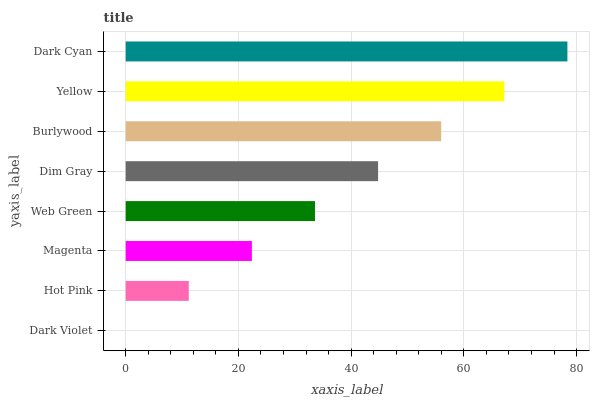Is Dark Violet the minimum?
Answer yes or no. Yes. Is Dark Cyan the maximum?
Answer yes or no. Yes. Is Hot Pink the minimum?
Answer yes or no. No. Is Hot Pink the maximum?
Answer yes or no. No. Is Hot Pink greater than Dark Violet?
Answer yes or no. Yes. Is Dark Violet less than Hot Pink?
Answer yes or no. Yes. Is Dark Violet greater than Hot Pink?
Answer yes or no. No. Is Hot Pink less than Dark Violet?
Answer yes or no. No. Is Dim Gray the high median?
Answer yes or no. Yes. Is Web Green the low median?
Answer yes or no. Yes. Is Yellow the high median?
Answer yes or no. No. Is Hot Pink the low median?
Answer yes or no. No. 